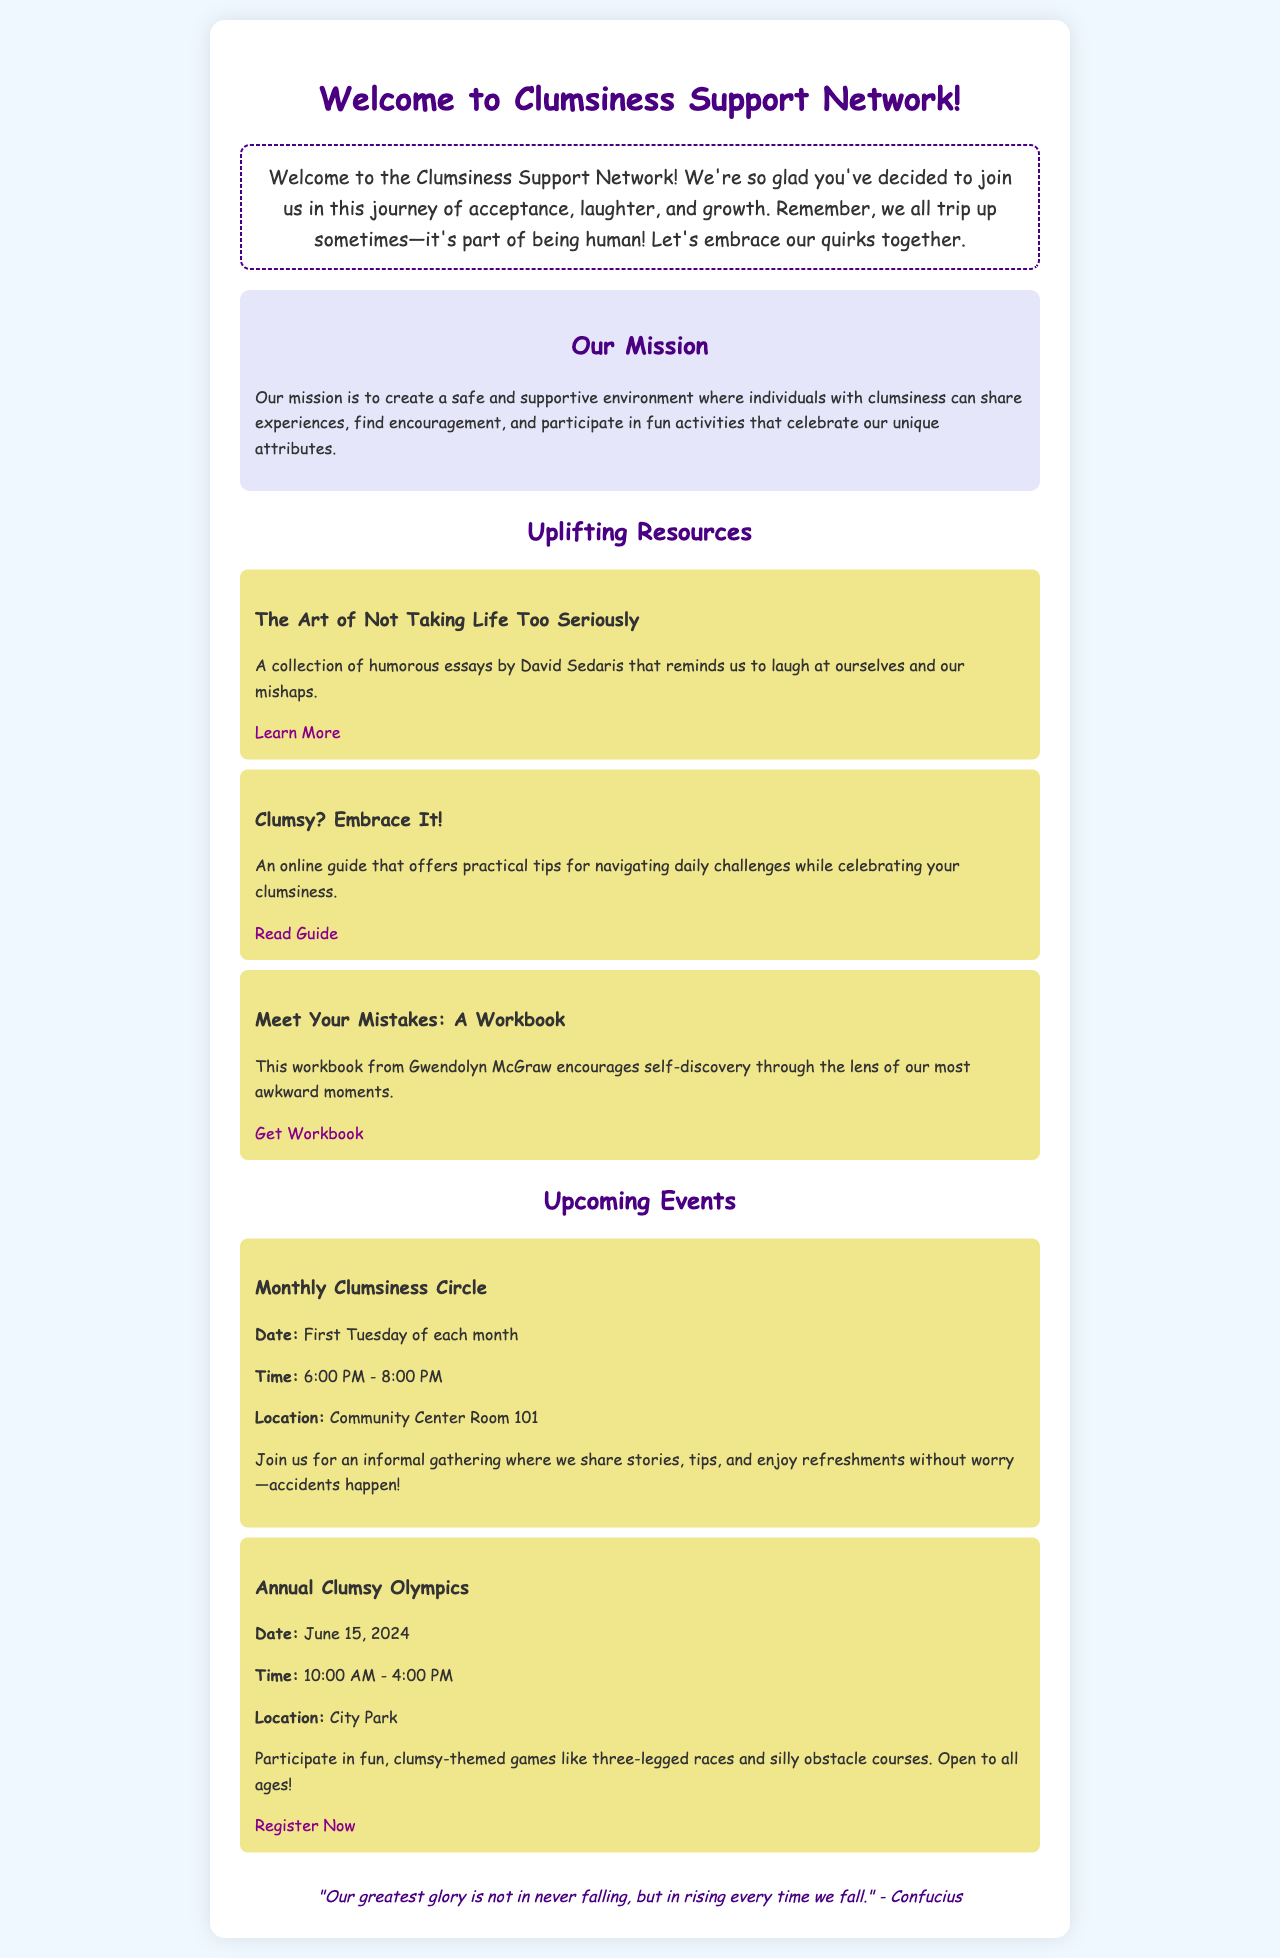What is the name of the support group? The name of the support group is mentioned in the title of the document, which is "Clumsiness Support Network".
Answer: Clumsiness Support Network What does the mission of the group emphasize? The mission emphasizes creating a safe and supportive environment for individuals to share experiences and find encouragement.
Answer: Safe and supportive environment What are the two uplifting resources listed? Two resources are specified in the document, which can be retrieved from the resources section. The resources listed are "The Art of Not Taking Life Too Seriously" and "Clumsy? Embrace It!".
Answer: The Art of Not Taking Life Too Seriously, Clumsy? Embrace It! When is the Monthly Clumsiness Circle held? The document states that the Monthly Clumsiness Circle takes place on the first Tuesday of each month.
Answer: First Tuesday of each month What quote is included in the document? A quote from Confucius that reflects the theme of resilience in facing clumsiness is presented in the document. The specific quote is provided.
Answer: "Our greatest glory is not in never falling, but in rising every time we fall." - Confucius How long does the Annual Clumsy Olympics last? The Annual Clumsy Olympics is mentioned to take place from 10:00 AM to 4:00 PM on June 15, 2024, making it a duration of 6 hours.
Answer: 6 hours 